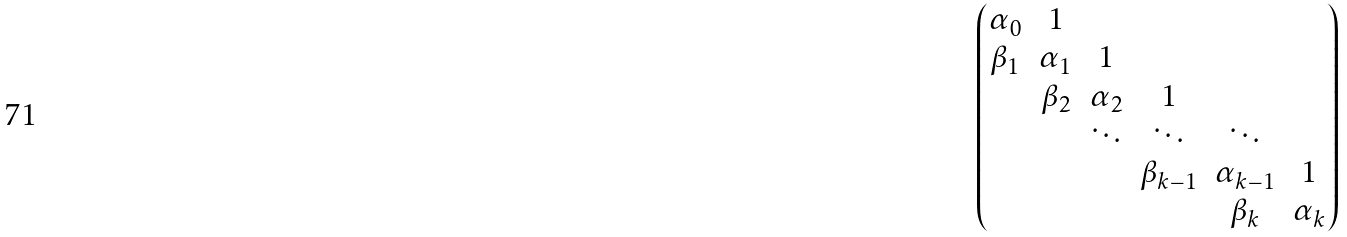<formula> <loc_0><loc_0><loc_500><loc_500>\begin{pmatrix} \alpha _ { 0 } & 1 & & & & \\ \beta _ { 1 } & \alpha _ { 1 } & 1 & & & \\ & \beta _ { 2 } & \alpha _ { 2 } & 1 & & \\ & & \ddots & \ddots & \ddots & \\ & & & \beta _ { k - 1 } & \alpha _ { k - 1 } & 1 \\ & & & & \beta _ { k } & \alpha _ { k } \end{pmatrix}</formula> 